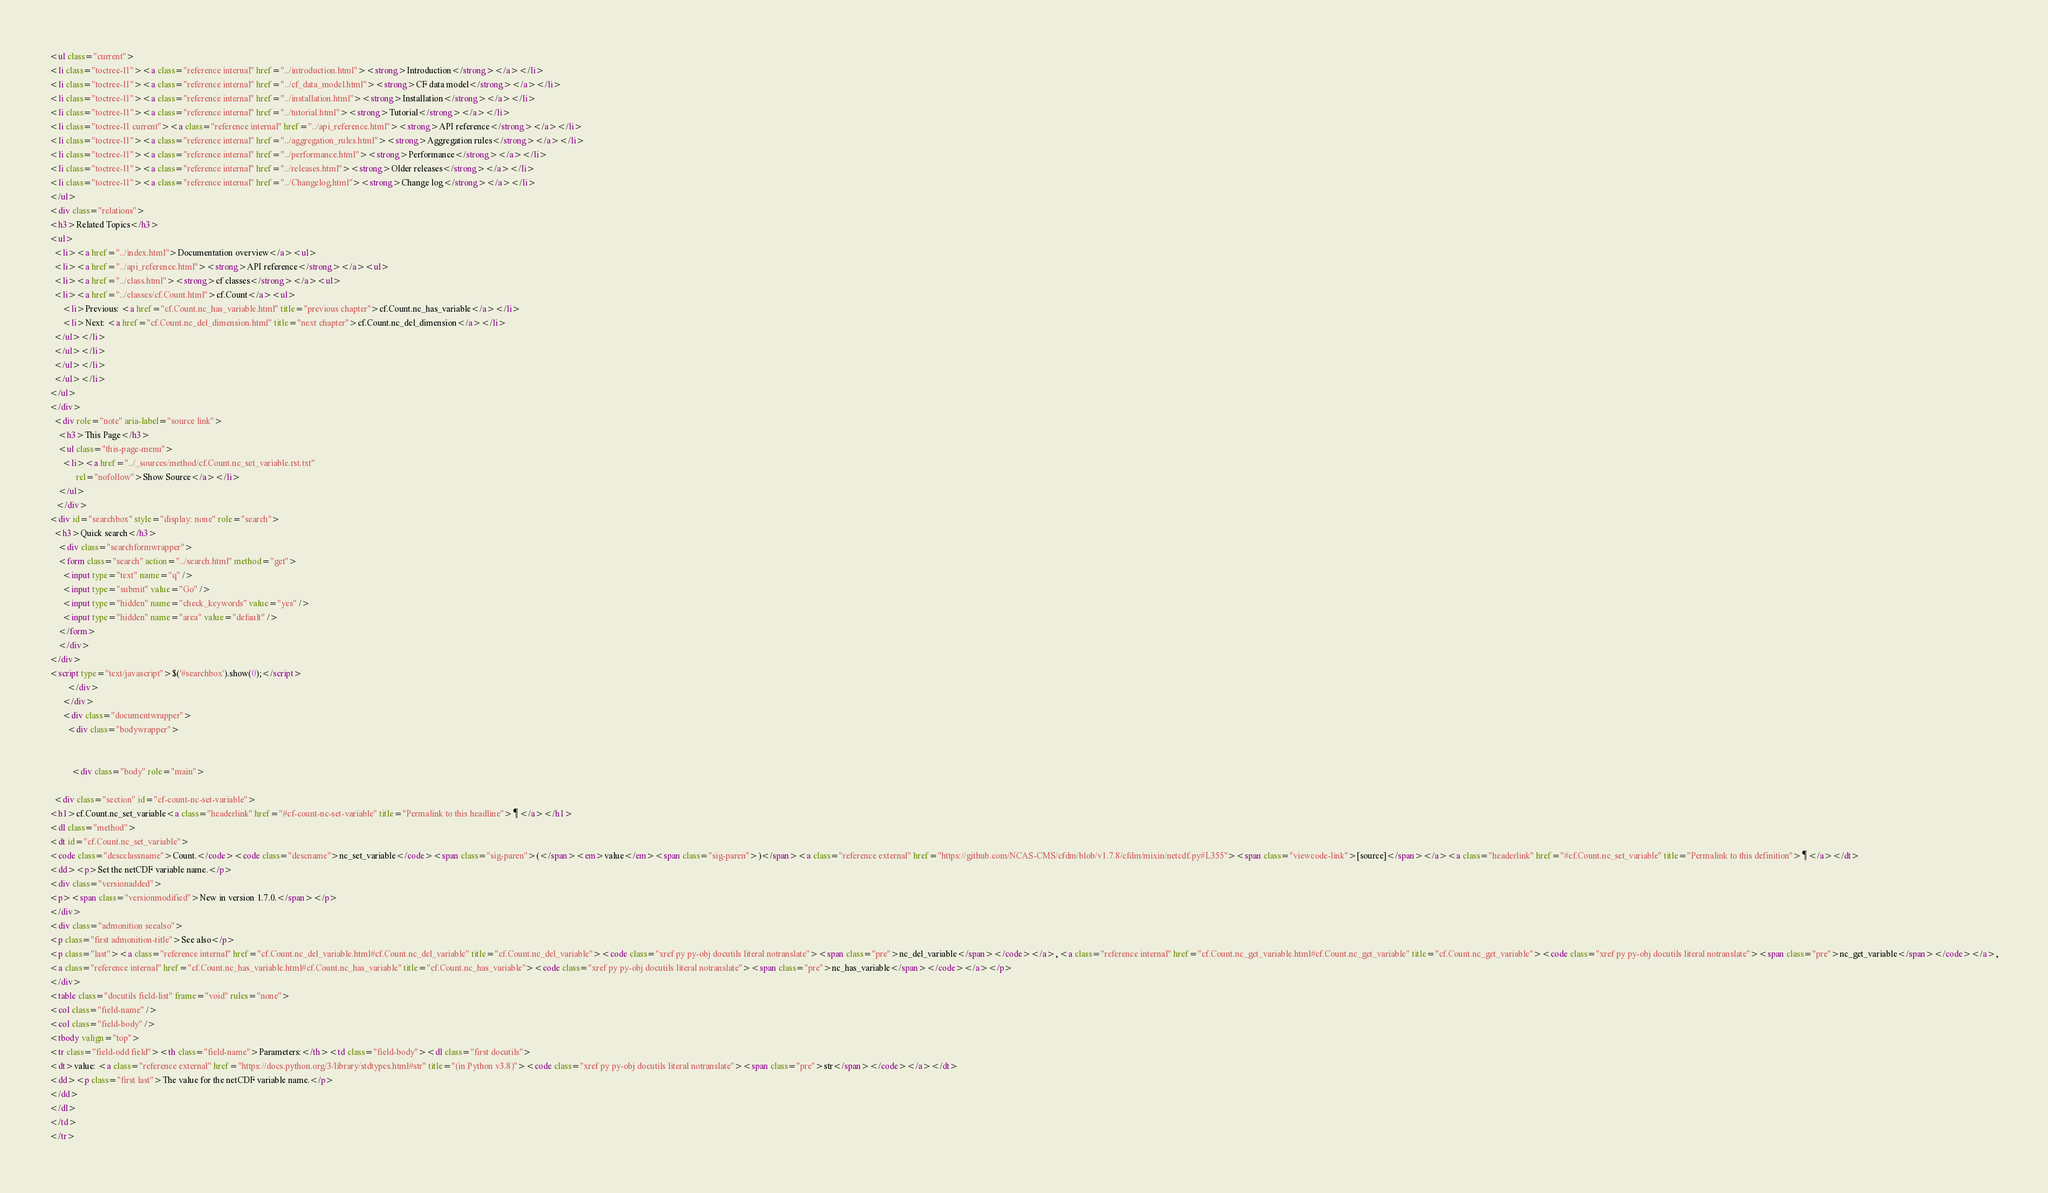<code> <loc_0><loc_0><loc_500><loc_500><_HTML_><ul class="current">
<li class="toctree-l1"><a class="reference internal" href="../introduction.html"><strong>Introduction</strong></a></li>
<li class="toctree-l1"><a class="reference internal" href="../cf_data_model.html"><strong>CF data model</strong></a></li>
<li class="toctree-l1"><a class="reference internal" href="../installation.html"><strong>Installation</strong></a></li>
<li class="toctree-l1"><a class="reference internal" href="../tutorial.html"><strong>Tutorial</strong></a></li>
<li class="toctree-l1 current"><a class="reference internal" href="../api_reference.html"><strong>API reference</strong></a></li>
<li class="toctree-l1"><a class="reference internal" href="../aggregation_rules.html"><strong>Aggregation rules</strong></a></li>
<li class="toctree-l1"><a class="reference internal" href="../performance.html"><strong>Performance</strong></a></li>
<li class="toctree-l1"><a class="reference internal" href="../releases.html"><strong>Older releases</strong></a></li>
<li class="toctree-l1"><a class="reference internal" href="../Changelog.html"><strong>Change log</strong></a></li>
</ul>
<div class="relations">
<h3>Related Topics</h3>
<ul>
  <li><a href="../index.html">Documentation overview</a><ul>
  <li><a href="../api_reference.html"><strong>API reference</strong></a><ul>
  <li><a href="../class.html"><strong>cf classes</strong></a><ul>
  <li><a href="../classes/cf.Count.html">cf.Count</a><ul>
      <li>Previous: <a href="cf.Count.nc_has_variable.html" title="previous chapter">cf.Count.nc_has_variable</a></li>
      <li>Next: <a href="cf.Count.nc_del_dimension.html" title="next chapter">cf.Count.nc_del_dimension</a></li>
  </ul></li>
  </ul></li>
  </ul></li>
  </ul></li>
</ul>
</div>
  <div role="note" aria-label="source link">
    <h3>This Page</h3>
    <ul class="this-page-menu">
      <li><a href="../_sources/method/cf.Count.nc_set_variable.rst.txt"
            rel="nofollow">Show Source</a></li>
    </ul>
   </div>
<div id="searchbox" style="display: none" role="search">
  <h3>Quick search</h3>
    <div class="searchformwrapper">
    <form class="search" action="../search.html" method="get">
      <input type="text" name="q" />
      <input type="submit" value="Go" />
      <input type="hidden" name="check_keywords" value="yes" />
      <input type="hidden" name="area" value="default" />
    </form>
    </div>
</div>
<script type="text/javascript">$('#searchbox').show(0);</script>
        </div>
      </div>
      <div class="documentwrapper">
        <div class="bodywrapper">
          

          <div class="body" role="main">
            
  <div class="section" id="cf-count-nc-set-variable">
<h1>cf.Count.nc_set_variable<a class="headerlink" href="#cf-count-nc-set-variable" title="Permalink to this headline">¶</a></h1>
<dl class="method">
<dt id="cf.Count.nc_set_variable">
<code class="descclassname">Count.</code><code class="descname">nc_set_variable</code><span class="sig-paren">(</span><em>value</em><span class="sig-paren">)</span><a class="reference external" href="https://github.com/NCAS-CMS/cfdm/blob/v1.7.8/cfdm/mixin/netcdf.py#L355"><span class="viewcode-link">[source]</span></a><a class="headerlink" href="#cf.Count.nc_set_variable" title="Permalink to this definition">¶</a></dt>
<dd><p>Set the netCDF variable name.</p>
<div class="versionadded">
<p><span class="versionmodified">New in version 1.7.0.</span></p>
</div>
<div class="admonition seealso">
<p class="first admonition-title">See also</p>
<p class="last"><a class="reference internal" href="cf.Count.nc_del_variable.html#cf.Count.nc_del_variable" title="cf.Count.nc_del_variable"><code class="xref py py-obj docutils literal notranslate"><span class="pre">nc_del_variable</span></code></a>, <a class="reference internal" href="cf.Count.nc_get_variable.html#cf.Count.nc_get_variable" title="cf.Count.nc_get_variable"><code class="xref py py-obj docutils literal notranslate"><span class="pre">nc_get_variable</span></code></a>,
<a class="reference internal" href="cf.Count.nc_has_variable.html#cf.Count.nc_has_variable" title="cf.Count.nc_has_variable"><code class="xref py py-obj docutils literal notranslate"><span class="pre">nc_has_variable</span></code></a></p>
</div>
<table class="docutils field-list" frame="void" rules="none">
<col class="field-name" />
<col class="field-body" />
<tbody valign="top">
<tr class="field-odd field"><th class="field-name">Parameters:</th><td class="field-body"><dl class="first docutils">
<dt>value: <a class="reference external" href="https://docs.python.org/3/library/stdtypes.html#str" title="(in Python v3.8)"><code class="xref py py-obj docutils literal notranslate"><span class="pre">str</span></code></a></dt>
<dd><p class="first last">The value for the netCDF variable name.</p>
</dd>
</dl>
</td>
</tr></code> 